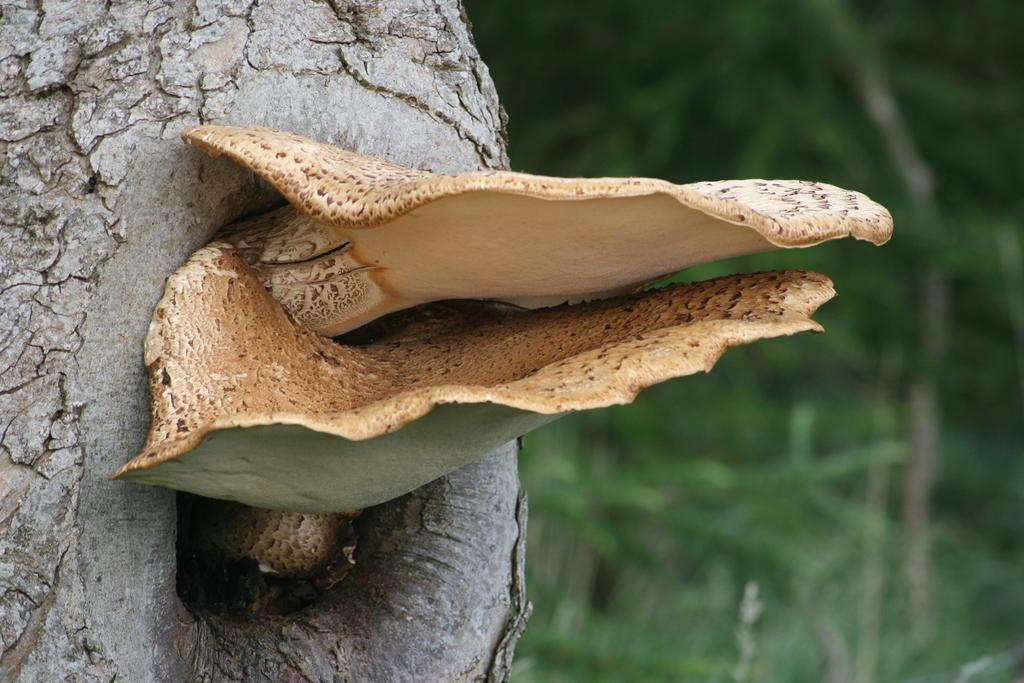What is located on the left side of the image? There is a tree trunk with a hole on the left side of the image. What is growing on the hole in the tree trunk? There are mushrooms on the hole. How would you describe the background of the image? The background of the image is green and blurred. Where is the doctor with the umbrella standing in the image? There is no doctor or umbrella present in the image. Can you tell me how many kittens are playing near the mushrooms? There are no kittens present in the image; only mushrooms are growing on the hole in the tree trunk. 